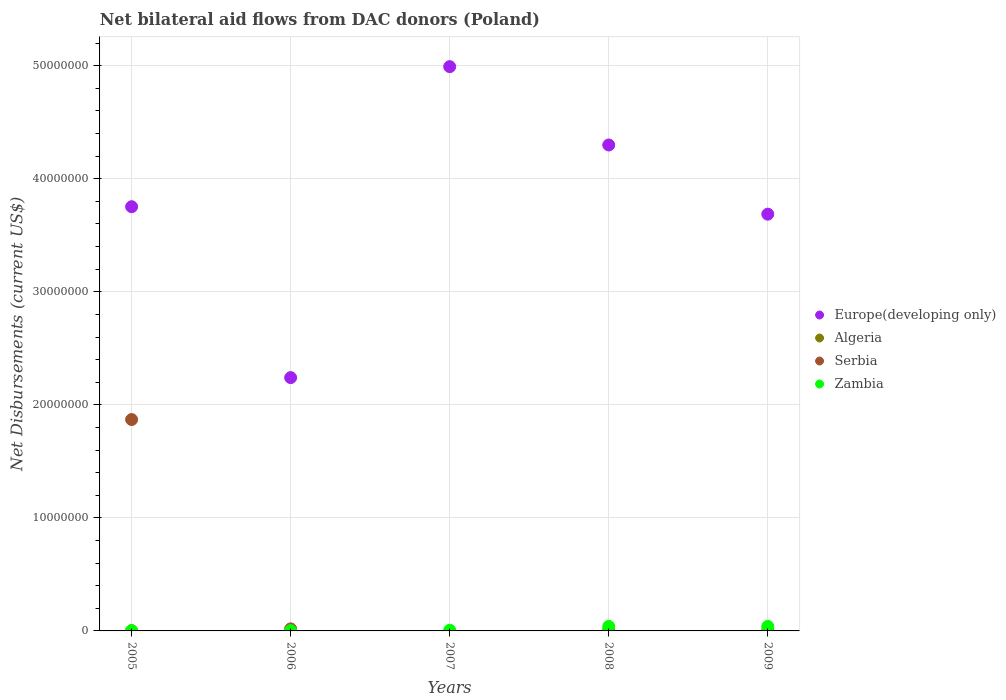How many different coloured dotlines are there?
Your answer should be very brief. 4. What is the net bilateral aid flows in Zambia in 2005?
Offer a terse response. 2.00e+04. Across all years, what is the maximum net bilateral aid flows in Serbia?
Make the answer very short. 1.87e+07. Across all years, what is the minimum net bilateral aid flows in Zambia?
Your response must be concise. 2.00e+04. What is the total net bilateral aid flows in Zambia in the graph?
Provide a short and direct response. 9.10e+05. What is the difference between the net bilateral aid flows in Zambia in 2005 and that in 2009?
Your answer should be compact. -3.80e+05. What is the difference between the net bilateral aid flows in Serbia in 2007 and the net bilateral aid flows in Zambia in 2009?
Make the answer very short. -4.00e+05. What is the average net bilateral aid flows in Europe(developing only) per year?
Keep it short and to the point. 3.79e+07. In the year 2006, what is the difference between the net bilateral aid flows in Serbia and net bilateral aid flows in Zambia?
Provide a short and direct response. 1.50e+05. What is the ratio of the net bilateral aid flows in Europe(developing only) in 2005 to that in 2007?
Your answer should be very brief. 0.75. Is the net bilateral aid flows in Zambia in 2005 less than that in 2007?
Your answer should be very brief. Yes. What is the difference between the highest and the second highest net bilateral aid flows in Europe(developing only)?
Ensure brevity in your answer.  6.93e+06. What is the difference between the highest and the lowest net bilateral aid flows in Zambia?
Your response must be concise. 3.80e+05. In how many years, is the net bilateral aid flows in Europe(developing only) greater than the average net bilateral aid flows in Europe(developing only) taken over all years?
Provide a short and direct response. 2. Is it the case that in every year, the sum of the net bilateral aid flows in Serbia and net bilateral aid flows in Zambia  is greater than the sum of net bilateral aid flows in Algeria and net bilateral aid flows in Europe(developing only)?
Provide a succinct answer. No. Is it the case that in every year, the sum of the net bilateral aid flows in Europe(developing only) and net bilateral aid flows in Serbia  is greater than the net bilateral aid flows in Algeria?
Ensure brevity in your answer.  Yes. Does the net bilateral aid flows in Zambia monotonically increase over the years?
Provide a short and direct response. No. Is the net bilateral aid flows in Algeria strictly less than the net bilateral aid flows in Europe(developing only) over the years?
Ensure brevity in your answer.  Yes. How many dotlines are there?
Your answer should be very brief. 4. How many years are there in the graph?
Ensure brevity in your answer.  5. What is the difference between two consecutive major ticks on the Y-axis?
Provide a short and direct response. 1.00e+07. Does the graph contain any zero values?
Offer a terse response. Yes. Does the graph contain grids?
Your response must be concise. Yes. What is the title of the graph?
Offer a terse response. Net bilateral aid flows from DAC donors (Poland). Does "Honduras" appear as one of the legend labels in the graph?
Ensure brevity in your answer.  No. What is the label or title of the X-axis?
Keep it short and to the point. Years. What is the label or title of the Y-axis?
Your answer should be very brief. Net Disbursements (current US$). What is the Net Disbursements (current US$) of Europe(developing only) in 2005?
Offer a terse response. 3.75e+07. What is the Net Disbursements (current US$) in Serbia in 2005?
Your answer should be very brief. 1.87e+07. What is the Net Disbursements (current US$) in Europe(developing only) in 2006?
Provide a succinct answer. 2.24e+07. What is the Net Disbursements (current US$) of Algeria in 2006?
Make the answer very short. 2.00e+04. What is the Net Disbursements (current US$) of Europe(developing only) in 2007?
Offer a very short reply. 4.99e+07. What is the Net Disbursements (current US$) of Europe(developing only) in 2008?
Your answer should be very brief. 4.30e+07. What is the Net Disbursements (current US$) of Algeria in 2008?
Offer a very short reply. 6.00e+04. What is the Net Disbursements (current US$) of Serbia in 2008?
Offer a terse response. 0. What is the Net Disbursements (current US$) of Zambia in 2008?
Provide a succinct answer. 4.00e+05. What is the Net Disbursements (current US$) in Europe(developing only) in 2009?
Ensure brevity in your answer.  3.69e+07. What is the Net Disbursements (current US$) in Serbia in 2009?
Offer a very short reply. 0. Across all years, what is the maximum Net Disbursements (current US$) of Europe(developing only)?
Your answer should be very brief. 4.99e+07. Across all years, what is the maximum Net Disbursements (current US$) in Algeria?
Your answer should be compact. 6.00e+04. Across all years, what is the maximum Net Disbursements (current US$) in Serbia?
Your answer should be very brief. 1.87e+07. Across all years, what is the minimum Net Disbursements (current US$) of Europe(developing only)?
Your response must be concise. 2.24e+07. Across all years, what is the minimum Net Disbursements (current US$) of Algeria?
Your response must be concise. 0. Across all years, what is the minimum Net Disbursements (current US$) in Zambia?
Offer a terse response. 2.00e+04. What is the total Net Disbursements (current US$) of Europe(developing only) in the graph?
Your response must be concise. 1.90e+08. What is the total Net Disbursements (current US$) in Algeria in the graph?
Ensure brevity in your answer.  1.40e+05. What is the total Net Disbursements (current US$) of Serbia in the graph?
Your answer should be compact. 1.89e+07. What is the total Net Disbursements (current US$) in Zambia in the graph?
Provide a short and direct response. 9.10e+05. What is the difference between the Net Disbursements (current US$) in Europe(developing only) in 2005 and that in 2006?
Provide a succinct answer. 1.51e+07. What is the difference between the Net Disbursements (current US$) of Serbia in 2005 and that in 2006?
Make the answer very short. 1.85e+07. What is the difference between the Net Disbursements (current US$) in Europe(developing only) in 2005 and that in 2007?
Keep it short and to the point. -1.24e+07. What is the difference between the Net Disbursements (current US$) in Europe(developing only) in 2005 and that in 2008?
Make the answer very short. -5.46e+06. What is the difference between the Net Disbursements (current US$) of Algeria in 2005 and that in 2008?
Provide a short and direct response. -4.00e+04. What is the difference between the Net Disbursements (current US$) in Zambia in 2005 and that in 2008?
Provide a succinct answer. -3.80e+05. What is the difference between the Net Disbursements (current US$) of Algeria in 2005 and that in 2009?
Ensure brevity in your answer.  -2.00e+04. What is the difference between the Net Disbursements (current US$) in Zambia in 2005 and that in 2009?
Make the answer very short. -3.80e+05. What is the difference between the Net Disbursements (current US$) of Europe(developing only) in 2006 and that in 2007?
Offer a very short reply. -2.75e+07. What is the difference between the Net Disbursements (current US$) of Zambia in 2006 and that in 2007?
Provide a succinct answer. -3.00e+04. What is the difference between the Net Disbursements (current US$) in Europe(developing only) in 2006 and that in 2008?
Your response must be concise. -2.06e+07. What is the difference between the Net Disbursements (current US$) of Algeria in 2006 and that in 2008?
Offer a very short reply. -4.00e+04. What is the difference between the Net Disbursements (current US$) of Zambia in 2006 and that in 2008?
Provide a succinct answer. -3.70e+05. What is the difference between the Net Disbursements (current US$) of Europe(developing only) in 2006 and that in 2009?
Keep it short and to the point. -1.45e+07. What is the difference between the Net Disbursements (current US$) in Zambia in 2006 and that in 2009?
Ensure brevity in your answer.  -3.70e+05. What is the difference between the Net Disbursements (current US$) in Europe(developing only) in 2007 and that in 2008?
Offer a very short reply. 6.93e+06. What is the difference between the Net Disbursements (current US$) of Zambia in 2007 and that in 2008?
Your answer should be very brief. -3.40e+05. What is the difference between the Net Disbursements (current US$) of Europe(developing only) in 2007 and that in 2009?
Your answer should be very brief. 1.30e+07. What is the difference between the Net Disbursements (current US$) of Zambia in 2007 and that in 2009?
Your answer should be very brief. -3.40e+05. What is the difference between the Net Disbursements (current US$) in Europe(developing only) in 2008 and that in 2009?
Offer a terse response. 6.12e+06. What is the difference between the Net Disbursements (current US$) of Algeria in 2008 and that in 2009?
Ensure brevity in your answer.  2.00e+04. What is the difference between the Net Disbursements (current US$) of Europe(developing only) in 2005 and the Net Disbursements (current US$) of Algeria in 2006?
Make the answer very short. 3.75e+07. What is the difference between the Net Disbursements (current US$) in Europe(developing only) in 2005 and the Net Disbursements (current US$) in Serbia in 2006?
Provide a short and direct response. 3.74e+07. What is the difference between the Net Disbursements (current US$) of Europe(developing only) in 2005 and the Net Disbursements (current US$) of Zambia in 2006?
Keep it short and to the point. 3.75e+07. What is the difference between the Net Disbursements (current US$) in Algeria in 2005 and the Net Disbursements (current US$) in Zambia in 2006?
Provide a succinct answer. -10000. What is the difference between the Net Disbursements (current US$) of Serbia in 2005 and the Net Disbursements (current US$) of Zambia in 2006?
Ensure brevity in your answer.  1.87e+07. What is the difference between the Net Disbursements (current US$) in Europe(developing only) in 2005 and the Net Disbursements (current US$) in Zambia in 2007?
Offer a terse response. 3.75e+07. What is the difference between the Net Disbursements (current US$) in Algeria in 2005 and the Net Disbursements (current US$) in Zambia in 2007?
Your answer should be compact. -4.00e+04. What is the difference between the Net Disbursements (current US$) of Serbia in 2005 and the Net Disbursements (current US$) of Zambia in 2007?
Offer a very short reply. 1.86e+07. What is the difference between the Net Disbursements (current US$) of Europe(developing only) in 2005 and the Net Disbursements (current US$) of Algeria in 2008?
Make the answer very short. 3.75e+07. What is the difference between the Net Disbursements (current US$) in Europe(developing only) in 2005 and the Net Disbursements (current US$) in Zambia in 2008?
Make the answer very short. 3.71e+07. What is the difference between the Net Disbursements (current US$) in Algeria in 2005 and the Net Disbursements (current US$) in Zambia in 2008?
Your response must be concise. -3.80e+05. What is the difference between the Net Disbursements (current US$) of Serbia in 2005 and the Net Disbursements (current US$) of Zambia in 2008?
Keep it short and to the point. 1.83e+07. What is the difference between the Net Disbursements (current US$) of Europe(developing only) in 2005 and the Net Disbursements (current US$) of Algeria in 2009?
Make the answer very short. 3.75e+07. What is the difference between the Net Disbursements (current US$) in Europe(developing only) in 2005 and the Net Disbursements (current US$) in Zambia in 2009?
Provide a succinct answer. 3.71e+07. What is the difference between the Net Disbursements (current US$) of Algeria in 2005 and the Net Disbursements (current US$) of Zambia in 2009?
Your answer should be very brief. -3.80e+05. What is the difference between the Net Disbursements (current US$) of Serbia in 2005 and the Net Disbursements (current US$) of Zambia in 2009?
Your answer should be compact. 1.83e+07. What is the difference between the Net Disbursements (current US$) of Europe(developing only) in 2006 and the Net Disbursements (current US$) of Zambia in 2007?
Your answer should be compact. 2.24e+07. What is the difference between the Net Disbursements (current US$) in Europe(developing only) in 2006 and the Net Disbursements (current US$) in Algeria in 2008?
Provide a succinct answer. 2.24e+07. What is the difference between the Net Disbursements (current US$) in Europe(developing only) in 2006 and the Net Disbursements (current US$) in Zambia in 2008?
Keep it short and to the point. 2.20e+07. What is the difference between the Net Disbursements (current US$) of Algeria in 2006 and the Net Disbursements (current US$) of Zambia in 2008?
Make the answer very short. -3.80e+05. What is the difference between the Net Disbursements (current US$) in Europe(developing only) in 2006 and the Net Disbursements (current US$) in Algeria in 2009?
Keep it short and to the point. 2.24e+07. What is the difference between the Net Disbursements (current US$) of Europe(developing only) in 2006 and the Net Disbursements (current US$) of Zambia in 2009?
Provide a succinct answer. 2.20e+07. What is the difference between the Net Disbursements (current US$) in Algeria in 2006 and the Net Disbursements (current US$) in Zambia in 2009?
Your response must be concise. -3.80e+05. What is the difference between the Net Disbursements (current US$) of Europe(developing only) in 2007 and the Net Disbursements (current US$) of Algeria in 2008?
Provide a short and direct response. 4.99e+07. What is the difference between the Net Disbursements (current US$) of Europe(developing only) in 2007 and the Net Disbursements (current US$) of Zambia in 2008?
Make the answer very short. 4.95e+07. What is the difference between the Net Disbursements (current US$) in Europe(developing only) in 2007 and the Net Disbursements (current US$) in Algeria in 2009?
Offer a terse response. 4.99e+07. What is the difference between the Net Disbursements (current US$) in Europe(developing only) in 2007 and the Net Disbursements (current US$) in Zambia in 2009?
Your answer should be very brief. 4.95e+07. What is the difference between the Net Disbursements (current US$) in Europe(developing only) in 2008 and the Net Disbursements (current US$) in Algeria in 2009?
Provide a short and direct response. 4.30e+07. What is the difference between the Net Disbursements (current US$) of Europe(developing only) in 2008 and the Net Disbursements (current US$) of Zambia in 2009?
Give a very brief answer. 4.26e+07. What is the average Net Disbursements (current US$) in Europe(developing only) per year?
Offer a very short reply. 3.79e+07. What is the average Net Disbursements (current US$) in Algeria per year?
Your answer should be very brief. 2.80e+04. What is the average Net Disbursements (current US$) in Serbia per year?
Offer a very short reply. 3.78e+06. What is the average Net Disbursements (current US$) of Zambia per year?
Give a very brief answer. 1.82e+05. In the year 2005, what is the difference between the Net Disbursements (current US$) in Europe(developing only) and Net Disbursements (current US$) in Algeria?
Provide a short and direct response. 3.75e+07. In the year 2005, what is the difference between the Net Disbursements (current US$) of Europe(developing only) and Net Disbursements (current US$) of Serbia?
Your response must be concise. 1.88e+07. In the year 2005, what is the difference between the Net Disbursements (current US$) of Europe(developing only) and Net Disbursements (current US$) of Zambia?
Make the answer very short. 3.75e+07. In the year 2005, what is the difference between the Net Disbursements (current US$) of Algeria and Net Disbursements (current US$) of Serbia?
Your response must be concise. -1.87e+07. In the year 2005, what is the difference between the Net Disbursements (current US$) of Serbia and Net Disbursements (current US$) of Zambia?
Keep it short and to the point. 1.87e+07. In the year 2006, what is the difference between the Net Disbursements (current US$) of Europe(developing only) and Net Disbursements (current US$) of Algeria?
Offer a very short reply. 2.24e+07. In the year 2006, what is the difference between the Net Disbursements (current US$) of Europe(developing only) and Net Disbursements (current US$) of Serbia?
Offer a terse response. 2.22e+07. In the year 2006, what is the difference between the Net Disbursements (current US$) in Europe(developing only) and Net Disbursements (current US$) in Zambia?
Provide a short and direct response. 2.24e+07. In the year 2006, what is the difference between the Net Disbursements (current US$) of Algeria and Net Disbursements (current US$) of Serbia?
Provide a succinct answer. -1.60e+05. In the year 2006, what is the difference between the Net Disbursements (current US$) in Algeria and Net Disbursements (current US$) in Zambia?
Ensure brevity in your answer.  -10000. In the year 2006, what is the difference between the Net Disbursements (current US$) of Serbia and Net Disbursements (current US$) of Zambia?
Offer a very short reply. 1.50e+05. In the year 2007, what is the difference between the Net Disbursements (current US$) of Europe(developing only) and Net Disbursements (current US$) of Zambia?
Keep it short and to the point. 4.99e+07. In the year 2008, what is the difference between the Net Disbursements (current US$) of Europe(developing only) and Net Disbursements (current US$) of Algeria?
Your response must be concise. 4.29e+07. In the year 2008, what is the difference between the Net Disbursements (current US$) of Europe(developing only) and Net Disbursements (current US$) of Zambia?
Your response must be concise. 4.26e+07. In the year 2009, what is the difference between the Net Disbursements (current US$) in Europe(developing only) and Net Disbursements (current US$) in Algeria?
Offer a very short reply. 3.68e+07. In the year 2009, what is the difference between the Net Disbursements (current US$) of Europe(developing only) and Net Disbursements (current US$) of Zambia?
Provide a short and direct response. 3.65e+07. In the year 2009, what is the difference between the Net Disbursements (current US$) in Algeria and Net Disbursements (current US$) in Zambia?
Give a very brief answer. -3.60e+05. What is the ratio of the Net Disbursements (current US$) in Europe(developing only) in 2005 to that in 2006?
Your response must be concise. 1.67. What is the ratio of the Net Disbursements (current US$) of Algeria in 2005 to that in 2006?
Make the answer very short. 1. What is the ratio of the Net Disbursements (current US$) of Serbia in 2005 to that in 2006?
Provide a succinct answer. 103.89. What is the ratio of the Net Disbursements (current US$) of Zambia in 2005 to that in 2006?
Ensure brevity in your answer.  0.67. What is the ratio of the Net Disbursements (current US$) of Europe(developing only) in 2005 to that in 2007?
Offer a very short reply. 0.75. What is the ratio of the Net Disbursements (current US$) in Europe(developing only) in 2005 to that in 2008?
Your response must be concise. 0.87. What is the ratio of the Net Disbursements (current US$) of Europe(developing only) in 2005 to that in 2009?
Provide a succinct answer. 1.02. What is the ratio of the Net Disbursements (current US$) of Europe(developing only) in 2006 to that in 2007?
Provide a short and direct response. 0.45. What is the ratio of the Net Disbursements (current US$) in Europe(developing only) in 2006 to that in 2008?
Your response must be concise. 0.52. What is the ratio of the Net Disbursements (current US$) in Zambia in 2006 to that in 2008?
Offer a very short reply. 0.07. What is the ratio of the Net Disbursements (current US$) in Europe(developing only) in 2006 to that in 2009?
Your answer should be very brief. 0.61. What is the ratio of the Net Disbursements (current US$) of Zambia in 2006 to that in 2009?
Your response must be concise. 0.07. What is the ratio of the Net Disbursements (current US$) in Europe(developing only) in 2007 to that in 2008?
Offer a very short reply. 1.16. What is the ratio of the Net Disbursements (current US$) in Europe(developing only) in 2007 to that in 2009?
Provide a succinct answer. 1.35. What is the ratio of the Net Disbursements (current US$) in Europe(developing only) in 2008 to that in 2009?
Give a very brief answer. 1.17. What is the ratio of the Net Disbursements (current US$) of Algeria in 2008 to that in 2009?
Provide a succinct answer. 1.5. What is the ratio of the Net Disbursements (current US$) of Zambia in 2008 to that in 2009?
Keep it short and to the point. 1. What is the difference between the highest and the second highest Net Disbursements (current US$) of Europe(developing only)?
Your response must be concise. 6.93e+06. What is the difference between the highest and the second highest Net Disbursements (current US$) in Algeria?
Offer a very short reply. 2.00e+04. What is the difference between the highest and the lowest Net Disbursements (current US$) in Europe(developing only)?
Ensure brevity in your answer.  2.75e+07. What is the difference between the highest and the lowest Net Disbursements (current US$) of Algeria?
Your response must be concise. 6.00e+04. What is the difference between the highest and the lowest Net Disbursements (current US$) in Serbia?
Provide a short and direct response. 1.87e+07. What is the difference between the highest and the lowest Net Disbursements (current US$) in Zambia?
Keep it short and to the point. 3.80e+05. 